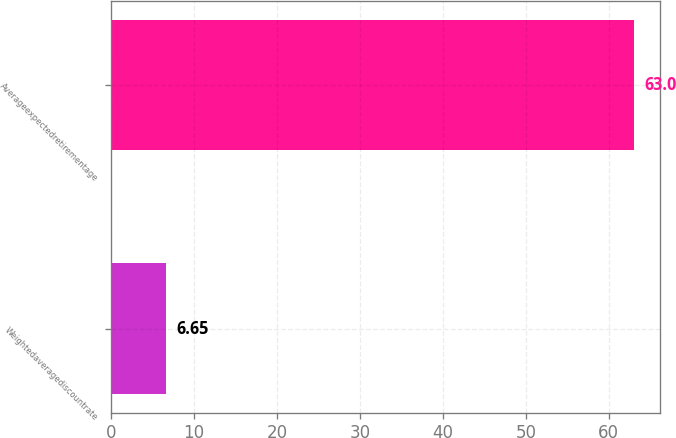<chart> <loc_0><loc_0><loc_500><loc_500><bar_chart><fcel>Weightedaveragediscountrate<fcel>Averageexpectedretirementage<nl><fcel>6.65<fcel>63<nl></chart> 